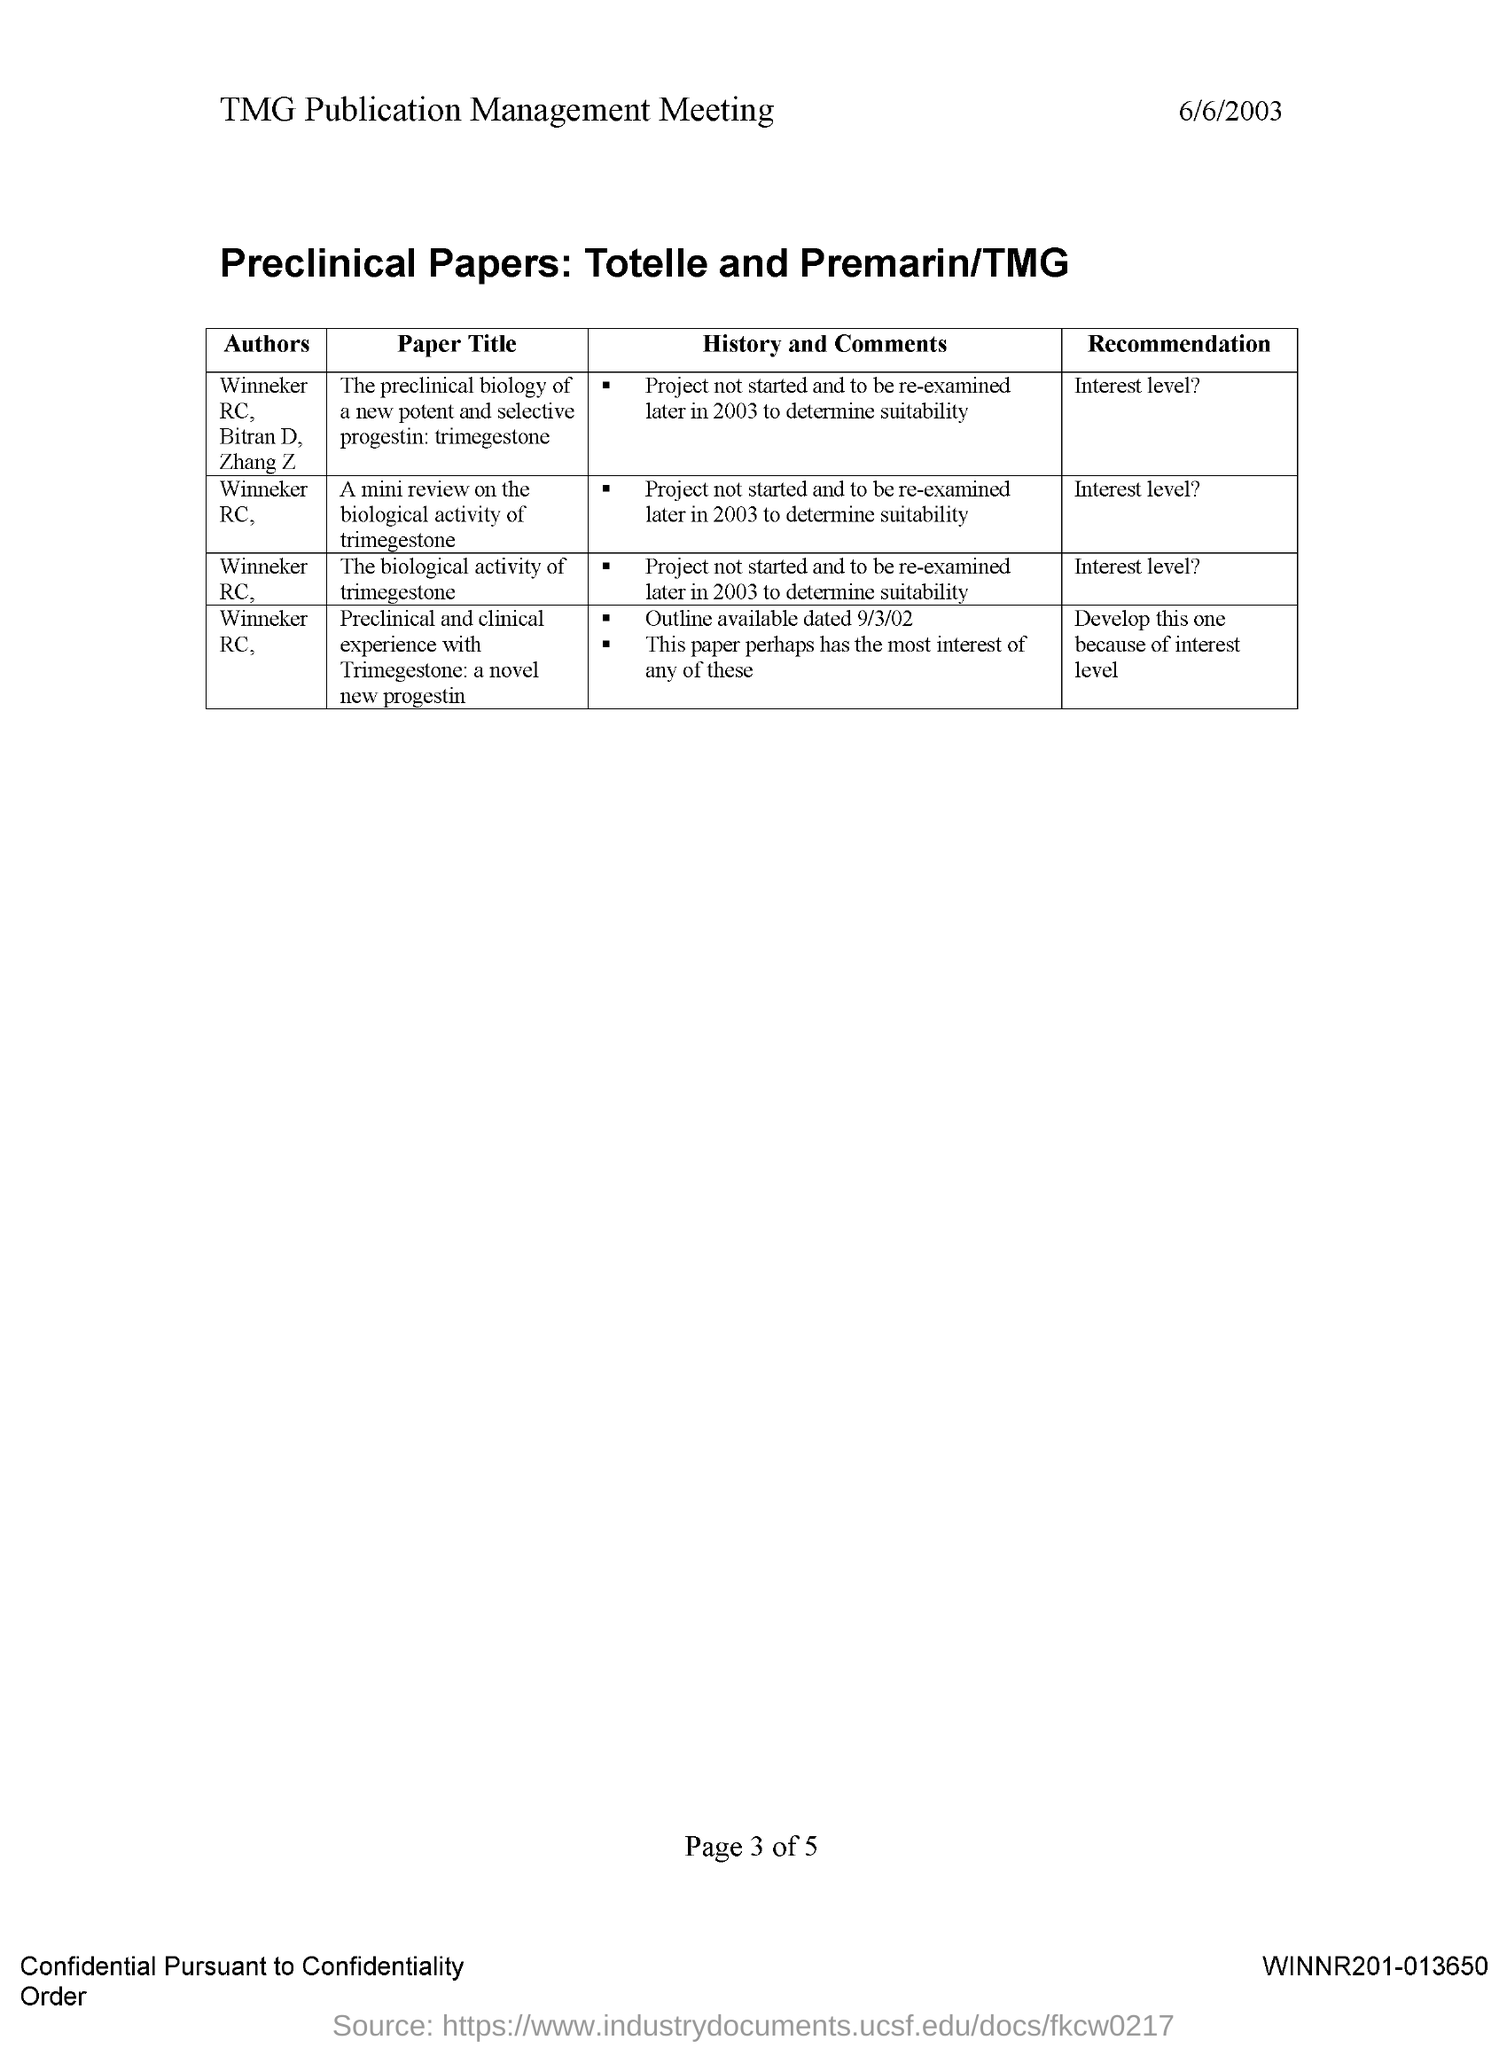Who is the author of the paper titled 'A mini review on the biological activity of trimegestone'?
Offer a terse response. Winneker RC,. Who is the author of the paper titled 'The biological activity of trimegestone'?
Ensure brevity in your answer.  Winneker rc. What is the date mentioned in this document?
Your answer should be very brief. 6/6/2003. What is the recommendation given for the paper titled 'The biological activity of trimegestone'?
Keep it short and to the point. Interest level?. Who are the authors of the article titled 'The preclinical biology of a new potent and selective progestin: trimegestone'?
Provide a succinct answer. Winneker rc, bitran d, zhang z. What is the recommendation given for the paper titled 'A mini review on the biological activity of trimegestone'?
Your response must be concise. Interest level?. 